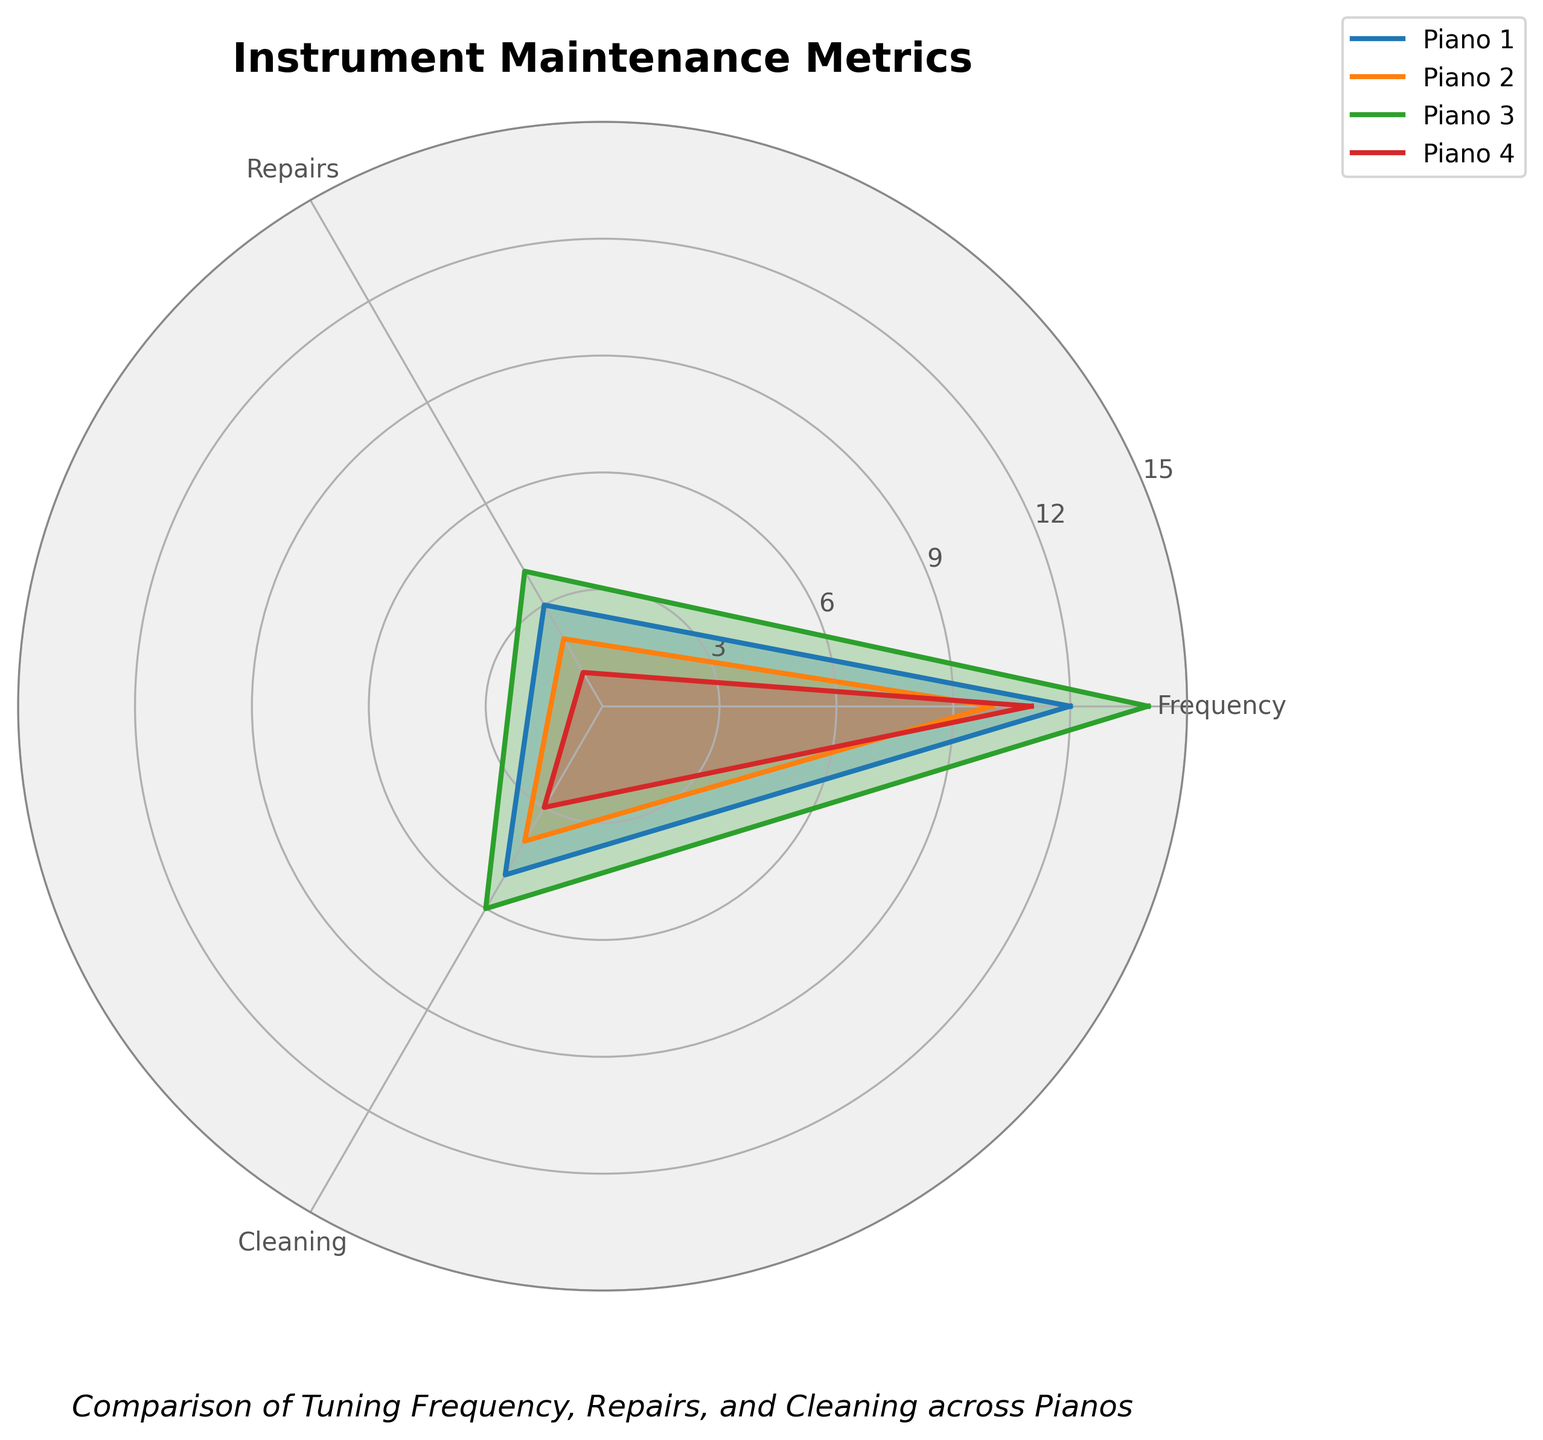What is the title of the radar chart? The title of the radar chart is usually located at the top center of the figure. In this radar chart, it reads "Instrument Maintenance Metrics".
Answer: Instrument Maintenance Metrics How many categories are being compared for each piano in the radar chart? By looking at the labels around the outer edge of the radar chart, we can count the distinct categories being compared for each piano. The categories labeled are Tuning Frequency, Repairs, and Cleaning, which makes a total of three categories.
Answer: Three Which piano has the highest Tuning Frequency? By locating the Tuning Frequency category on the radar chart and comparing the values plotted for each piano, we can identify the one with the highest value. Piano 3 noticeably extends further than the others in this category.
Answer: Piano 3 How frequently is Piano 4 repaired compared to Piano 2? To answer this, locate the Repairs category on the radar chart and compare the plot values of Piano 4 and Piano 2 in this category. Piano 4 has a value of 1, whereas Piano 2 has a value of 2.
Answer: Less frequently Which piano requires the most Cleaning? By examining the Cleaning category, observe which piano extends the furthest out from the center in this category. Piano 3 reaches the highest value in this category.
Answer: Piano 3 Which piano is the least tuned? Within the Tuning Frequency category, find the piano with the shortest extension from the center. Piano 2 shows the smallest value in this category.
Answer: Piano 2 What's the average number of Repairs across all pianos? Extract the number of Repairs for each piano (3, 2, 4, 1). Sum them up: 3 + 2 + 4 + 1 = 10. Then divide by the number of pianos, which is 4. The average is 10 / 4 = 2.5.
Answer: 2.5 Among the three metrics (Tuning Frequency, Repairs, Cleaning), which one shows the widest range of values across all pianos? Calculate the range (difference between the highest and lowest values) for each metric. Tuning Frequency ranges from 10 to 14 (range = 4), Repairs from 1 to 4 (range = 3), and Cleaning from 3 to 6 (range = 3). The smallest range is Repairs and Cleaning, and the widest is Tuning Frequency.
Answer: Tuning Frequency 